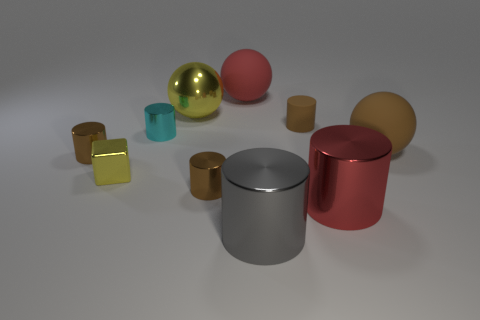How many brown cylinders must be subtracted to get 1 brown cylinders? 2 Subtract all big yellow metallic spheres. How many spheres are left? 2 Subtract 1 blocks. How many blocks are left? 0 Subtract all balls. How many objects are left? 7 Subtract 0 purple blocks. How many objects are left? 10 Subtract all green cylinders. Subtract all brown balls. How many cylinders are left? 6 Subtract all green cylinders. How many yellow balls are left? 1 Subtract all large yellow spheres. Subtract all big gray shiny cylinders. How many objects are left? 8 Add 1 tiny yellow objects. How many tiny yellow objects are left? 2 Add 1 small brown shiny things. How many small brown shiny things exist? 3 